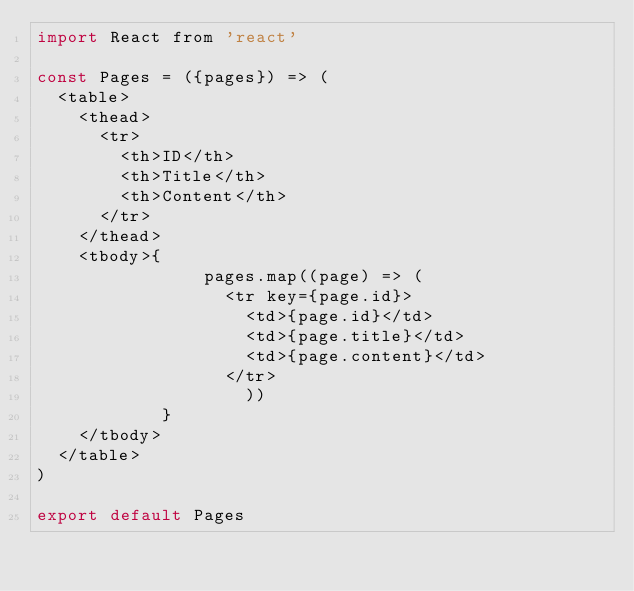<code> <loc_0><loc_0><loc_500><loc_500><_JavaScript_>import React from 'react'

const Pages = ({pages}) => (
  <table>
    <thead>
      <tr>
        <th>ID</th>
        <th>Title</th>
        <th>Content</th>
      </tr>
    </thead>
    <tbody>{
                pages.map((page) => (
                  <tr key={page.id}>
                    <td>{page.id}</td>
                    <td>{page.title}</td>
                    <td>{page.content}</td>
                  </tr>
                    ))
            }
    </tbody>
  </table>
)

export default Pages
</code> 